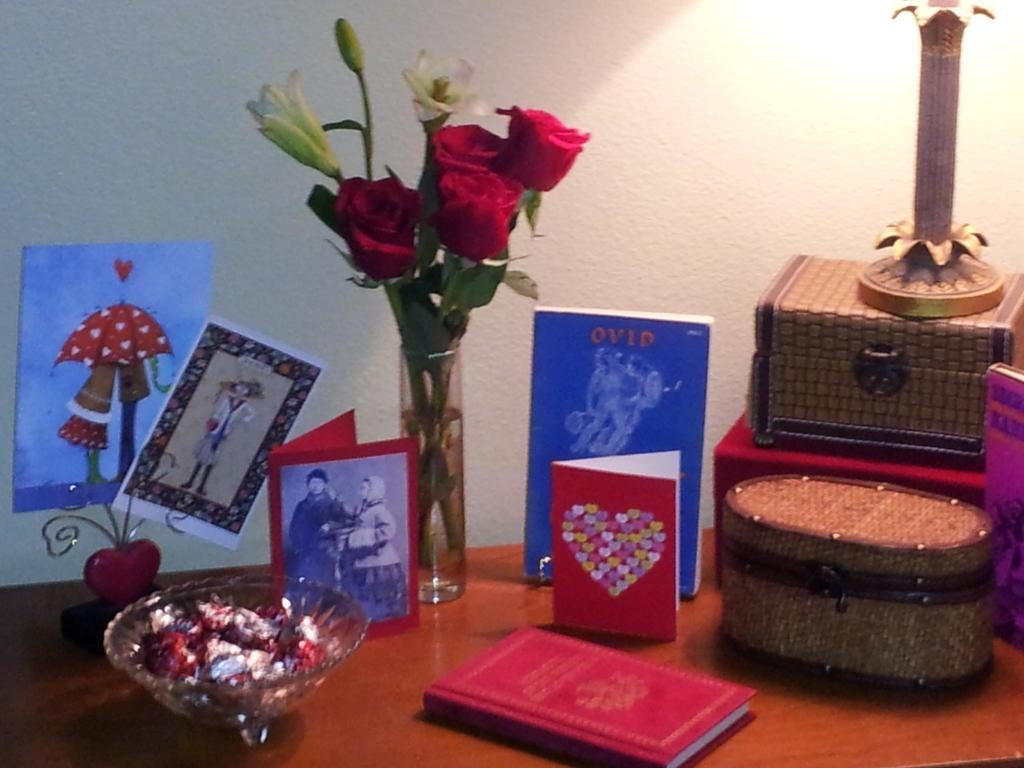What piece of furniture is present in the image? There is a table in the image. What is on the table? There is a bowl of chocolates, a group of cards, roses, and wooden boxes on the table. Can you describe the contents of the bowl on the table? The bowl on the table contains chocolates. What type of flowers are on the table? The flowers on the table are roses. What type of wine is being served in the image? There is no wine present in the image; it features a table with a bowl of chocolates, a group of cards, roses, and wooden boxes. 